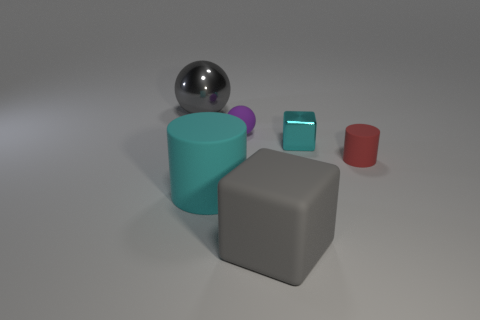Add 1 large red shiny objects. How many objects exist? 7 Subtract all cylinders. How many objects are left? 4 Add 4 cyan cylinders. How many cyan cylinders exist? 5 Subtract 0 cyan spheres. How many objects are left? 6 Subtract all purple matte balls. Subtract all tiny purple things. How many objects are left? 4 Add 2 cyan cylinders. How many cyan cylinders are left? 3 